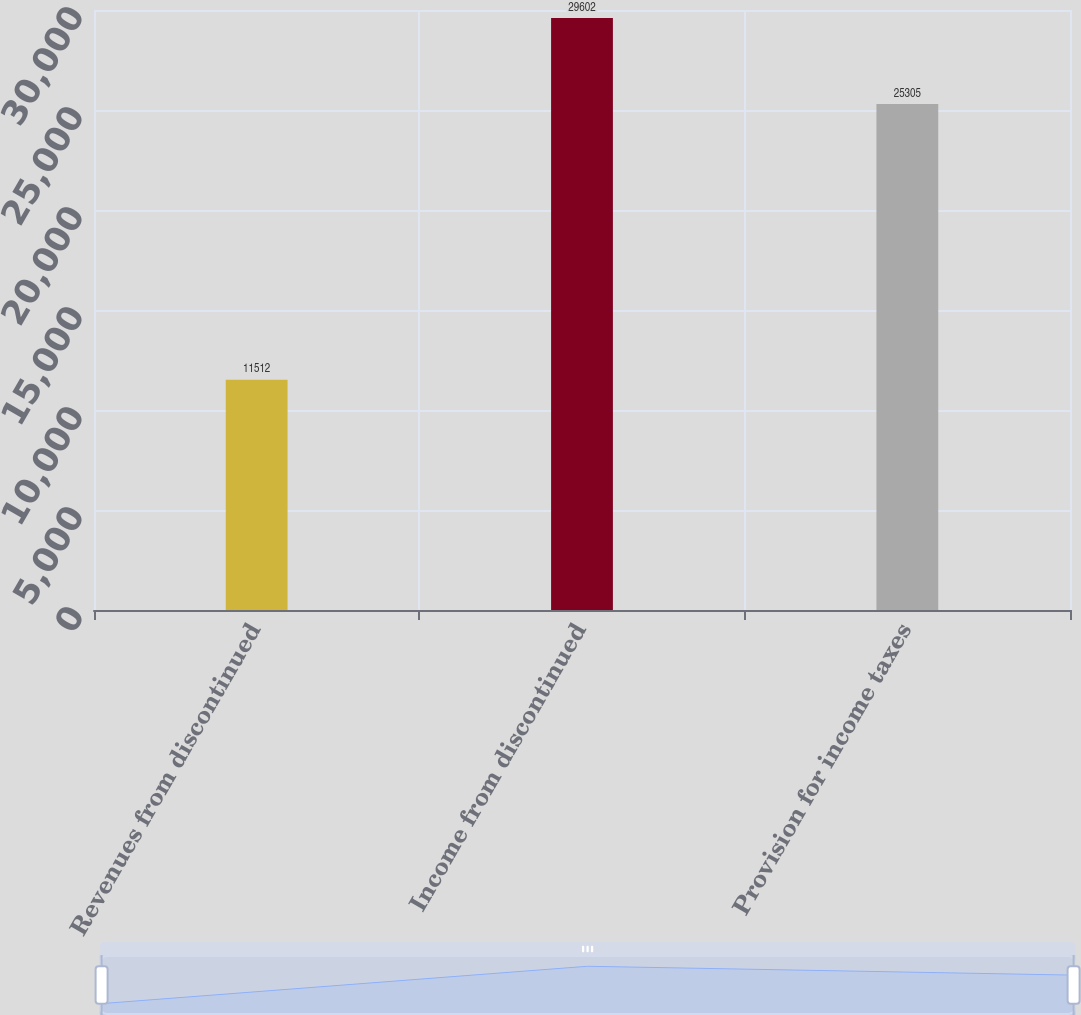Convert chart to OTSL. <chart><loc_0><loc_0><loc_500><loc_500><bar_chart><fcel>Revenues from discontinued<fcel>Income from discontinued<fcel>Provision for income taxes<nl><fcel>11512<fcel>29602<fcel>25305<nl></chart> 